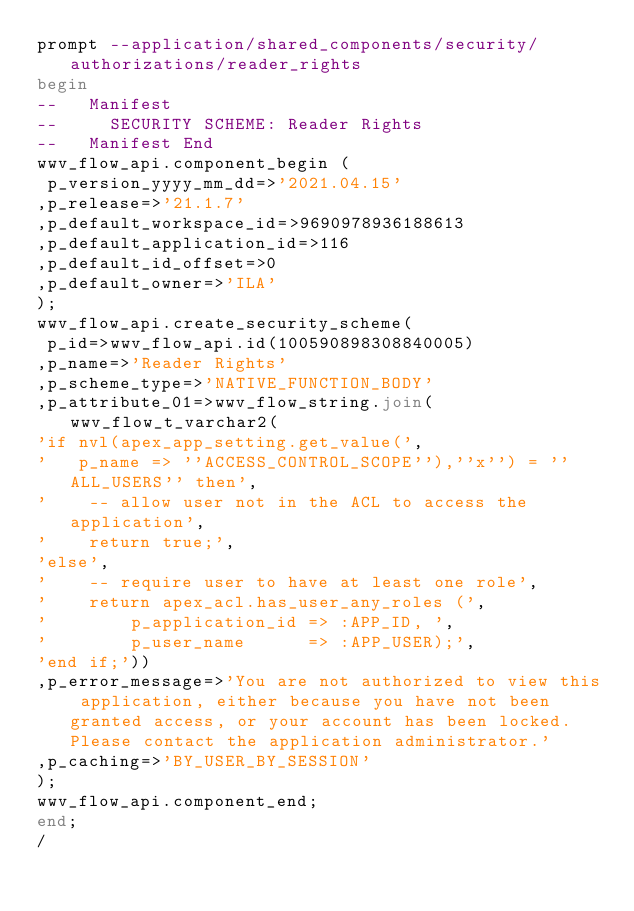Convert code to text. <code><loc_0><loc_0><loc_500><loc_500><_SQL_>prompt --application/shared_components/security/authorizations/reader_rights
begin
--   Manifest
--     SECURITY SCHEME: Reader Rights
--   Manifest End
wwv_flow_api.component_begin (
 p_version_yyyy_mm_dd=>'2021.04.15'
,p_release=>'21.1.7'
,p_default_workspace_id=>9690978936188613
,p_default_application_id=>116
,p_default_id_offset=>0
,p_default_owner=>'ILA'
);
wwv_flow_api.create_security_scheme(
 p_id=>wwv_flow_api.id(100590898308840005)
,p_name=>'Reader Rights'
,p_scheme_type=>'NATIVE_FUNCTION_BODY'
,p_attribute_01=>wwv_flow_string.join(wwv_flow_t_varchar2(
'if nvl(apex_app_setting.get_value(',
'   p_name => ''ACCESS_CONTROL_SCOPE''),''x'') = ''ALL_USERS'' then',
'    -- allow user not in the ACL to access the application',
'    return true;',
'else',
'    -- require user to have at least one role',
'    return apex_acl.has_user_any_roles (',
'        p_application_id => :APP_ID, ',
'        p_user_name      => :APP_USER);',
'end if;'))
,p_error_message=>'You are not authorized to view this application, either because you have not been granted access, or your account has been locked. Please contact the application administrator.'
,p_caching=>'BY_USER_BY_SESSION'
);
wwv_flow_api.component_end;
end;
/
</code> 